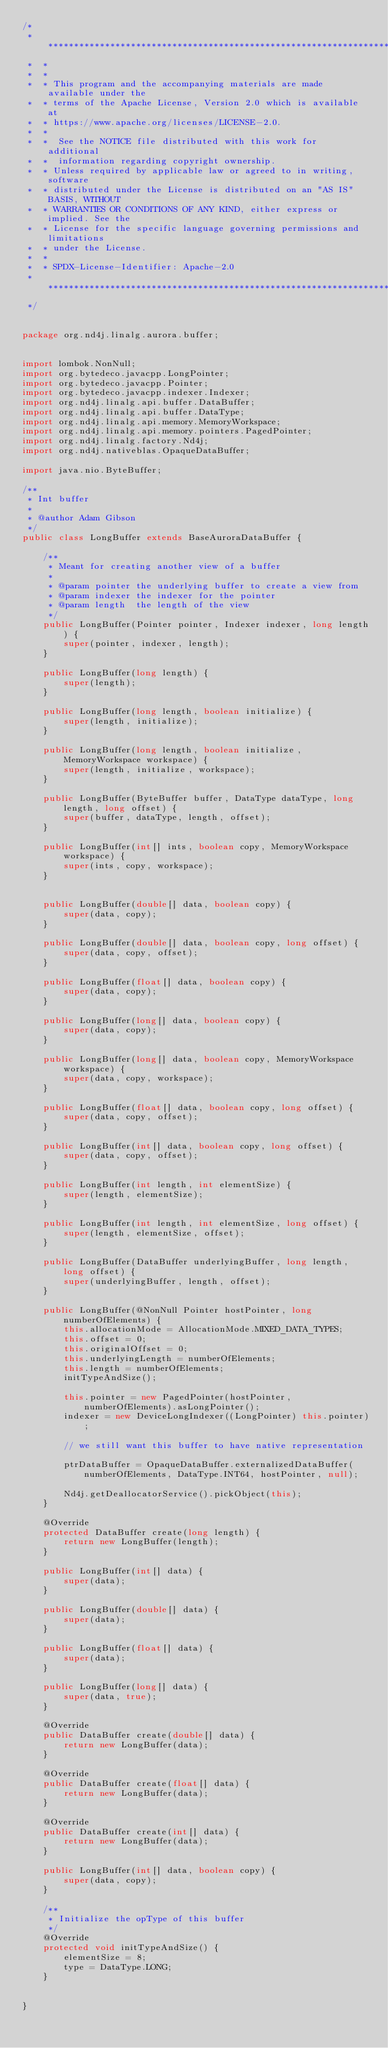<code> <loc_0><loc_0><loc_500><loc_500><_Java_>/*
 *  ******************************************************************************
 *  *
 *  *
 *  * This program and the accompanying materials are made available under the
 *  * terms of the Apache License, Version 2.0 which is available at
 *  * https://www.apache.org/licenses/LICENSE-2.0.
 *  *
 *  *  See the NOTICE file distributed with this work for additional
 *  *  information regarding copyright ownership.
 *  * Unless required by applicable law or agreed to in writing, software
 *  * distributed under the License is distributed on an "AS IS" BASIS, WITHOUT
 *  * WARRANTIES OR CONDITIONS OF ANY KIND, either express or implied. See the
 *  * License for the specific language governing permissions and limitations
 *  * under the License.
 *  *
 *  * SPDX-License-Identifier: Apache-2.0
 *  *****************************************************************************
 */


package org.nd4j.linalg.aurora.buffer;


import lombok.NonNull;
import org.bytedeco.javacpp.LongPointer;
import org.bytedeco.javacpp.Pointer;
import org.bytedeco.javacpp.indexer.Indexer;
import org.nd4j.linalg.api.buffer.DataBuffer;
import org.nd4j.linalg.api.buffer.DataType;
import org.nd4j.linalg.api.memory.MemoryWorkspace;
import org.nd4j.linalg.api.memory.pointers.PagedPointer;
import org.nd4j.linalg.factory.Nd4j;
import org.nd4j.nativeblas.OpaqueDataBuffer;

import java.nio.ByteBuffer;

/**
 * Int buffer
 *
 * @author Adam Gibson
 */
public class LongBuffer extends BaseAuroraDataBuffer {

    /**
     * Meant for creating another view of a buffer
     *
     * @param pointer the underlying buffer to create a view from
     * @param indexer the indexer for the pointer
     * @param length  the length of the view
     */
    public LongBuffer(Pointer pointer, Indexer indexer, long length) {
        super(pointer, indexer, length);
    }

    public LongBuffer(long length) {
        super(length);
    }

    public LongBuffer(long length, boolean initialize) {
        super(length, initialize);
    }

    public LongBuffer(long length, boolean initialize, MemoryWorkspace workspace) {
        super(length, initialize, workspace);
    }

    public LongBuffer(ByteBuffer buffer, DataType dataType, long length, long offset) {
        super(buffer, dataType, length, offset);
    }

    public LongBuffer(int[] ints, boolean copy, MemoryWorkspace workspace) {
        super(ints, copy, workspace);
    }


    public LongBuffer(double[] data, boolean copy) {
        super(data, copy);
    }

    public LongBuffer(double[] data, boolean copy, long offset) {
        super(data, copy, offset);
    }

    public LongBuffer(float[] data, boolean copy) {
        super(data, copy);
    }

    public LongBuffer(long[] data, boolean copy) {
        super(data, copy);
    }

    public LongBuffer(long[] data, boolean copy, MemoryWorkspace workspace) {
        super(data, copy, workspace);
    }

    public LongBuffer(float[] data, boolean copy, long offset) {
        super(data, copy, offset);
    }

    public LongBuffer(int[] data, boolean copy, long offset) {
        super(data, copy, offset);
    }

    public LongBuffer(int length, int elementSize) {
        super(length, elementSize);
    }

    public LongBuffer(int length, int elementSize, long offset) {
        super(length, elementSize, offset);
    }

    public LongBuffer(DataBuffer underlyingBuffer, long length, long offset) {
        super(underlyingBuffer, length, offset);
    }

    public LongBuffer(@NonNull Pointer hostPointer, long numberOfElements) {
        this.allocationMode = AllocationMode.MIXED_DATA_TYPES;
        this.offset = 0;
        this.originalOffset = 0;
        this.underlyingLength = numberOfElements;
        this.length = numberOfElements;
        initTypeAndSize();

        this.pointer = new PagedPointer(hostPointer, numberOfElements).asLongPointer();
        indexer = new DeviceLongIndexer((LongPointer) this.pointer);

        // we still want this buffer to have native representation

        ptrDataBuffer = OpaqueDataBuffer.externalizedDataBuffer(numberOfElements, DataType.INT64, hostPointer, null);

        Nd4j.getDeallocatorService().pickObject(this);
    }

    @Override
    protected DataBuffer create(long length) {
        return new LongBuffer(length);
    }

    public LongBuffer(int[] data) {
        super(data);
    }

    public LongBuffer(double[] data) {
        super(data);
    }

    public LongBuffer(float[] data) {
        super(data);
    }

    public LongBuffer(long[] data) {
        super(data, true);
    }

    @Override
    public DataBuffer create(double[] data) {
        return new LongBuffer(data);
    }

    @Override
    public DataBuffer create(float[] data) {
        return new LongBuffer(data);
    }

    @Override
    public DataBuffer create(int[] data) {
        return new LongBuffer(data);
    }

    public LongBuffer(int[] data, boolean copy) {
        super(data, copy);
    }

    /**
     * Initialize the opType of this buffer
     */
    @Override
    protected void initTypeAndSize() {
        elementSize = 8;
        type = DataType.LONG;
    }


}
</code> 